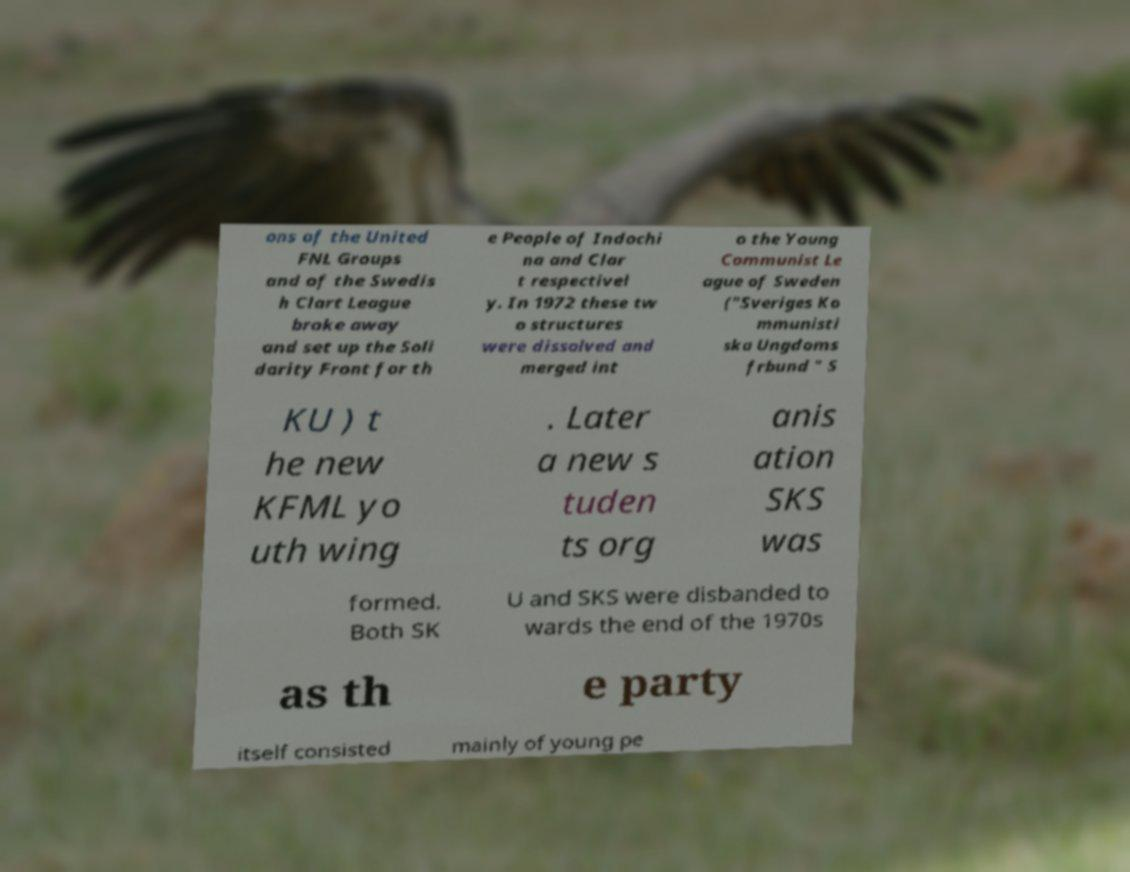I need the written content from this picture converted into text. Can you do that? ons of the United FNL Groups and of the Swedis h Clart League broke away and set up the Soli darity Front for th e People of Indochi na and Clar t respectivel y. In 1972 these tw o structures were dissolved and merged int o the Young Communist Le ague of Sweden ("Sveriges Ko mmunisti ska Ungdoms frbund " S KU ) t he new KFML yo uth wing . Later a new s tuden ts org anis ation SKS was formed. Both SK U and SKS were disbanded to wards the end of the 1970s as th e party itself consisted mainly of young pe 